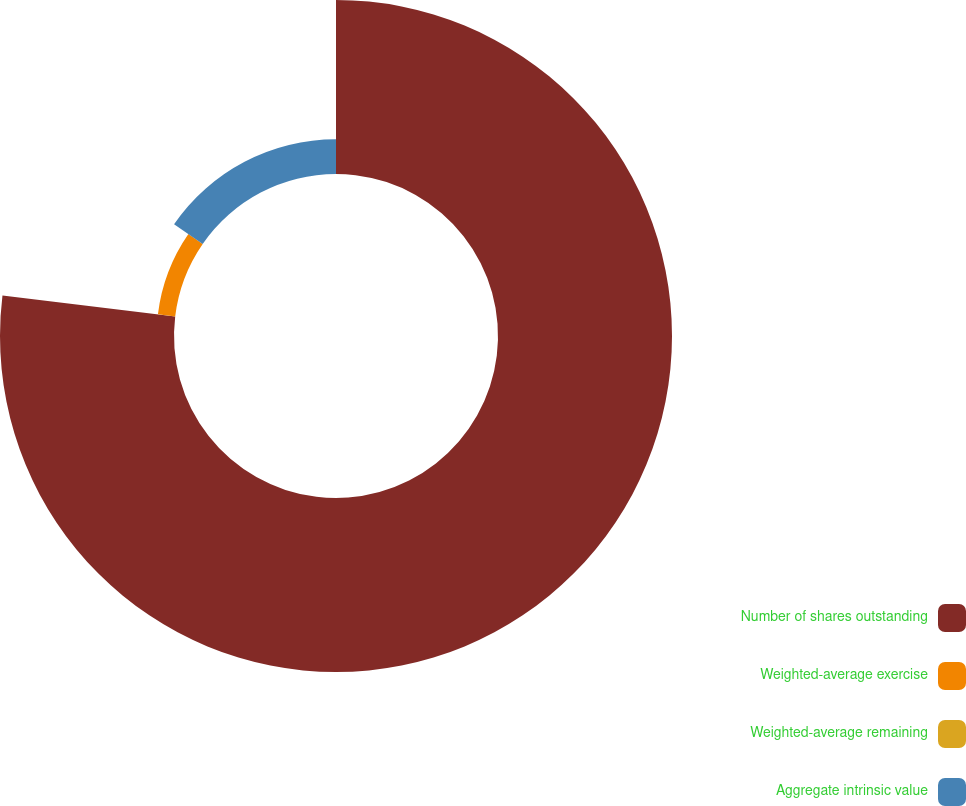Convert chart to OTSL. <chart><loc_0><loc_0><loc_500><loc_500><pie_chart><fcel>Number of shares outstanding<fcel>Weighted-average exercise<fcel>Weighted-average remaining<fcel>Aggregate intrinsic value<nl><fcel>76.92%<fcel>7.69%<fcel>0.0%<fcel>15.38%<nl></chart> 